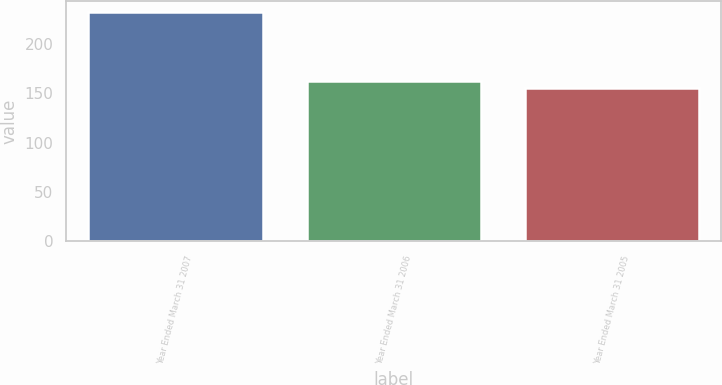Convert chart. <chart><loc_0><loc_0><loc_500><loc_500><bar_chart><fcel>Year Ended March 31 2007<fcel>Year Ended March 31 2006<fcel>Year Ended March 31 2005<nl><fcel>232<fcel>162.7<fcel>155<nl></chart> 